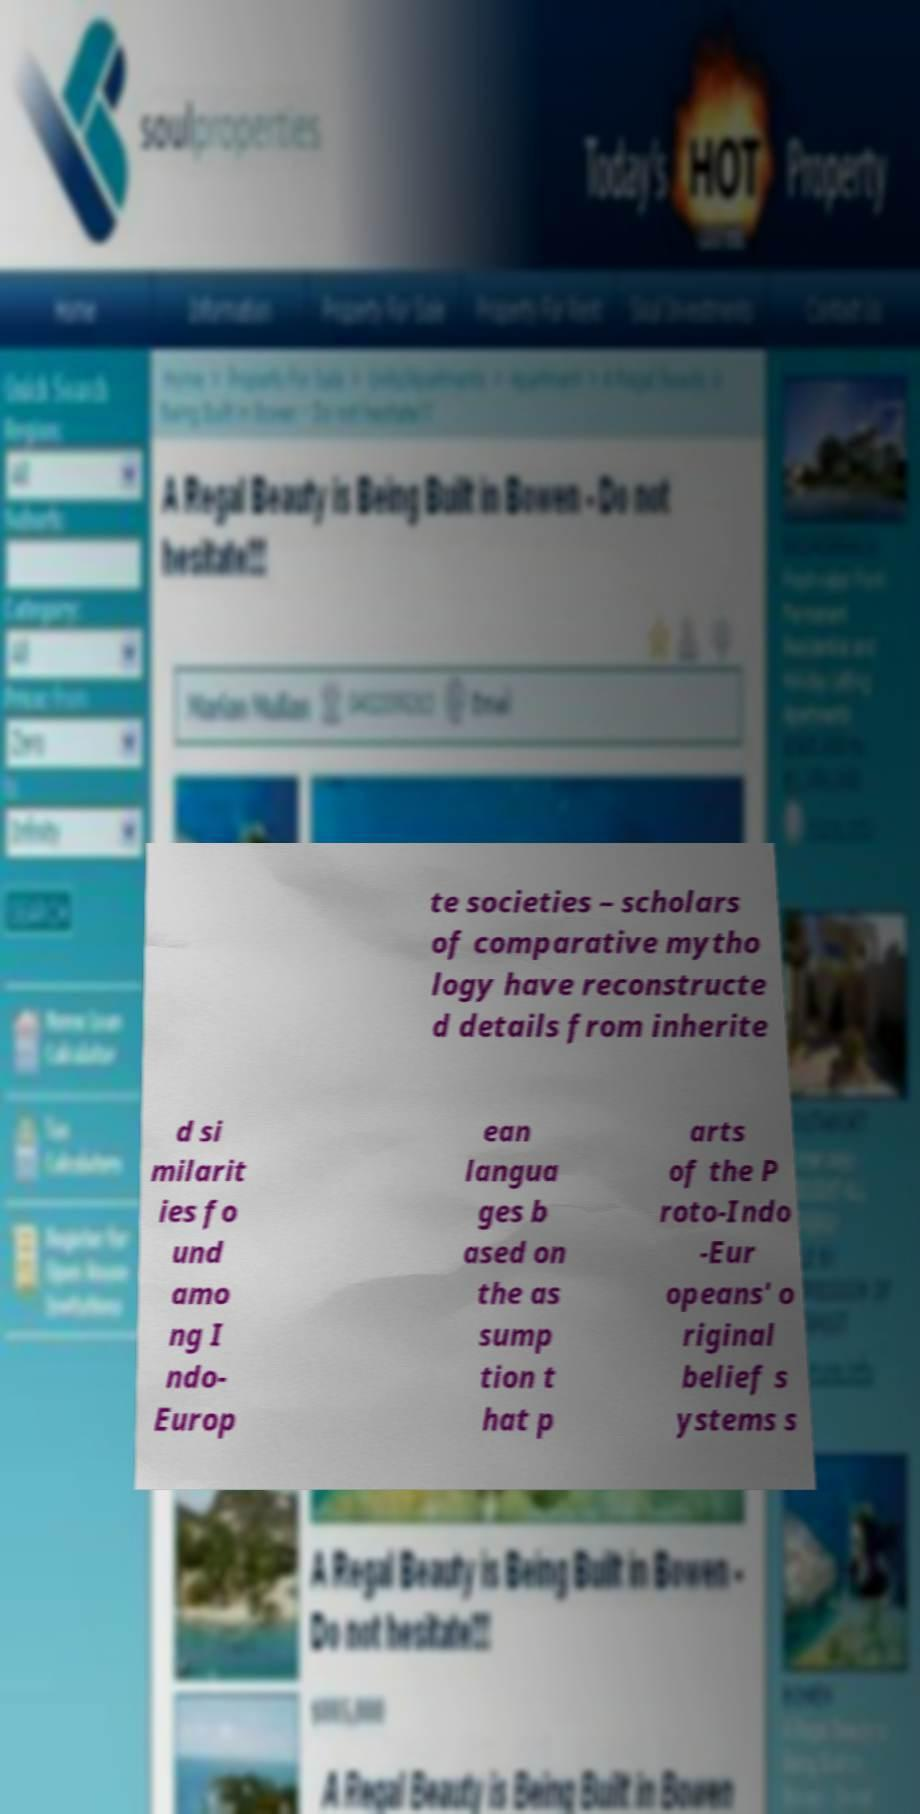What messages or text are displayed in this image? I need them in a readable, typed format. te societies – scholars of comparative mytho logy have reconstructe d details from inherite d si milarit ies fo und amo ng I ndo- Europ ean langua ges b ased on the as sump tion t hat p arts of the P roto-Indo -Eur opeans' o riginal belief s ystems s 